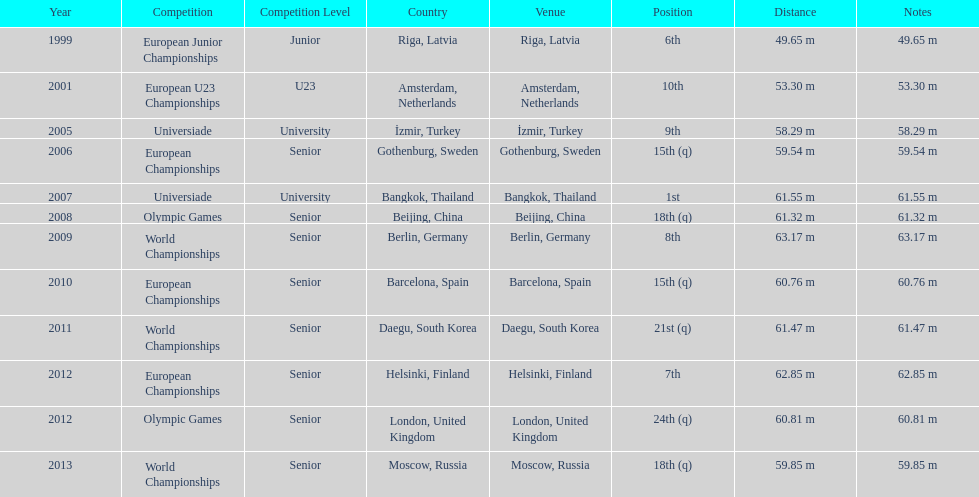What was the last competition he was in before the 2012 olympics? European Championships. 